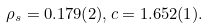<formula> <loc_0><loc_0><loc_500><loc_500>\rho _ { s } = 0 . 1 7 9 ( 2 ) , c = 1 . 6 5 2 ( 1 ) .</formula> 